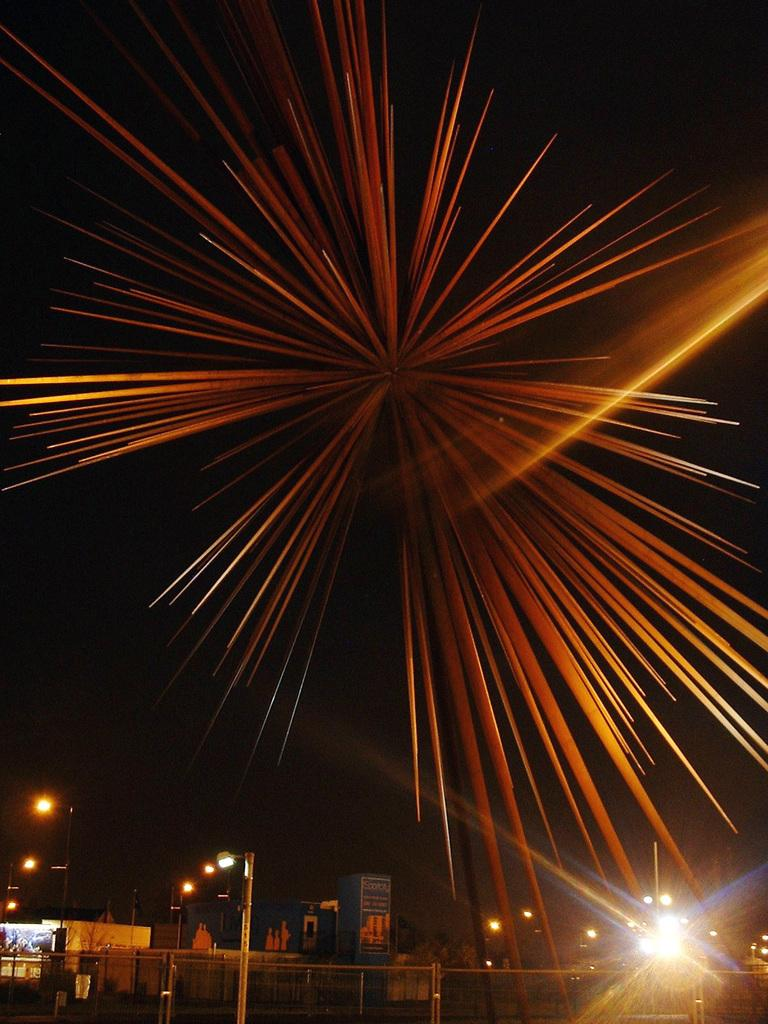What type of structures can be seen in the image? There are buildings in the image. What type of lighting is present in the image? There are street lights in the image. What is attached to the poles in the image? There is a poster attached to the poles in the image. What type of barrier is visible in the image? There is a fence in the image. What can be seen in the sky in the image? There are sparkles visible in the sky. Can you see the maid cleaning the buildings in the image? There is no maid present in the image, and no cleaning activity is depicted. What type of brush is used to create the sparkles in the sky? There is no brush present in the image, and the sparkles are not created by any visible tool or object. 